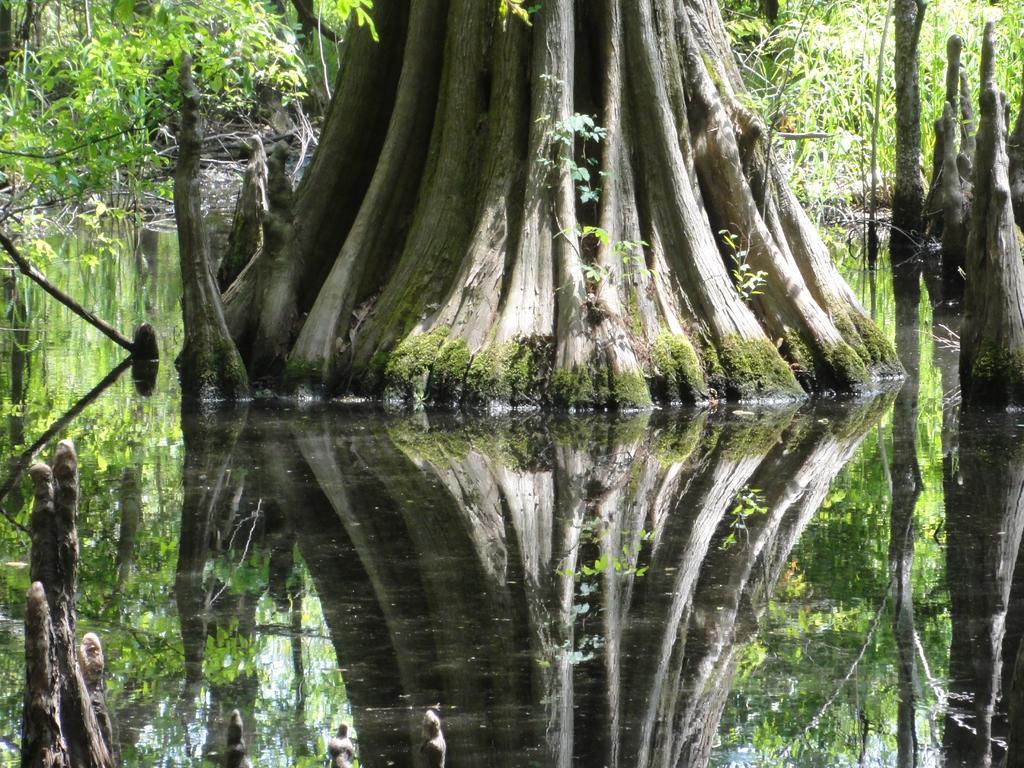Could you give a brief overview of what you see in this image? In the given image i can see a tree trunks,water,plants,wooden sticks and trees. 